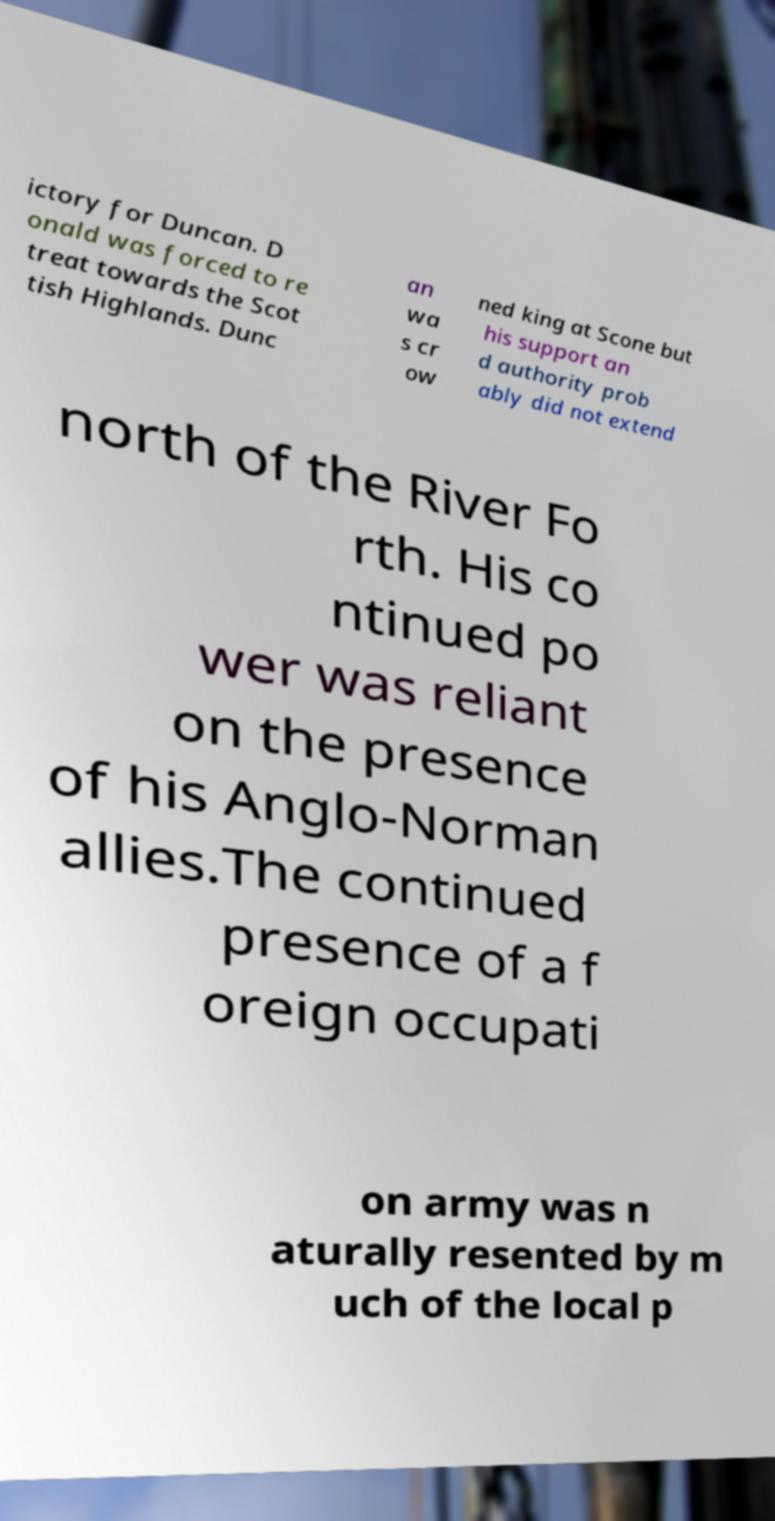Can you read and provide the text displayed in the image?This photo seems to have some interesting text. Can you extract and type it out for me? ictory for Duncan. D onald was forced to re treat towards the Scot tish Highlands. Dunc an wa s cr ow ned king at Scone but his support an d authority prob ably did not extend north of the River Fo rth. His co ntinued po wer was reliant on the presence of his Anglo-Norman allies.The continued presence of a f oreign occupati on army was n aturally resented by m uch of the local p 